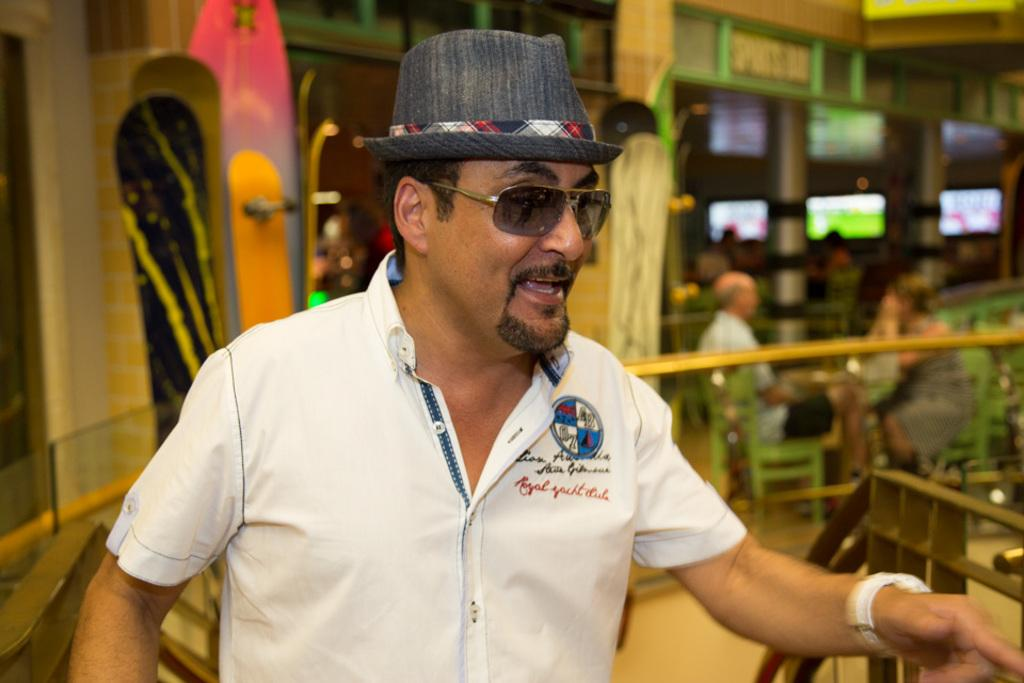What is the main subject of the image? There is a person in the image. What can be observed about the person's attire? The person is wearing clothes and a hat. Can you describe the background of the image? The background of the image is blurred. What type of thread is being used to create the marble coast in the image? There is no thread, marble, or coast present in the image. 